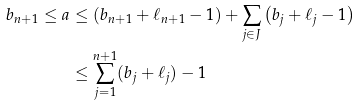<formula> <loc_0><loc_0><loc_500><loc_500>b _ { n + 1 } \leq a & \leq \left ( b _ { n + 1 } + \ell _ { n + 1 } - 1 \right ) + \sum _ { j \in J } \left ( b _ { j } + \ell _ { j } - 1 \right ) \\ & \leq \sum _ { j = 1 } ^ { n + 1 } ( b _ { j } + \ell _ { j } ) - 1</formula> 